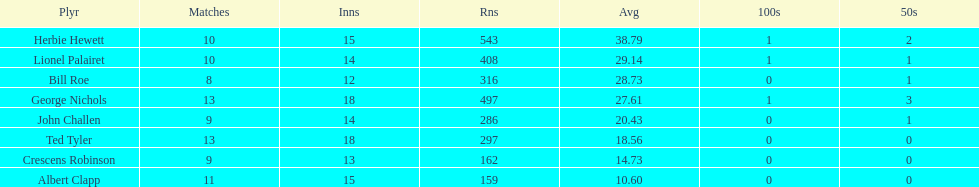How many more runs does john have than albert? 127. 